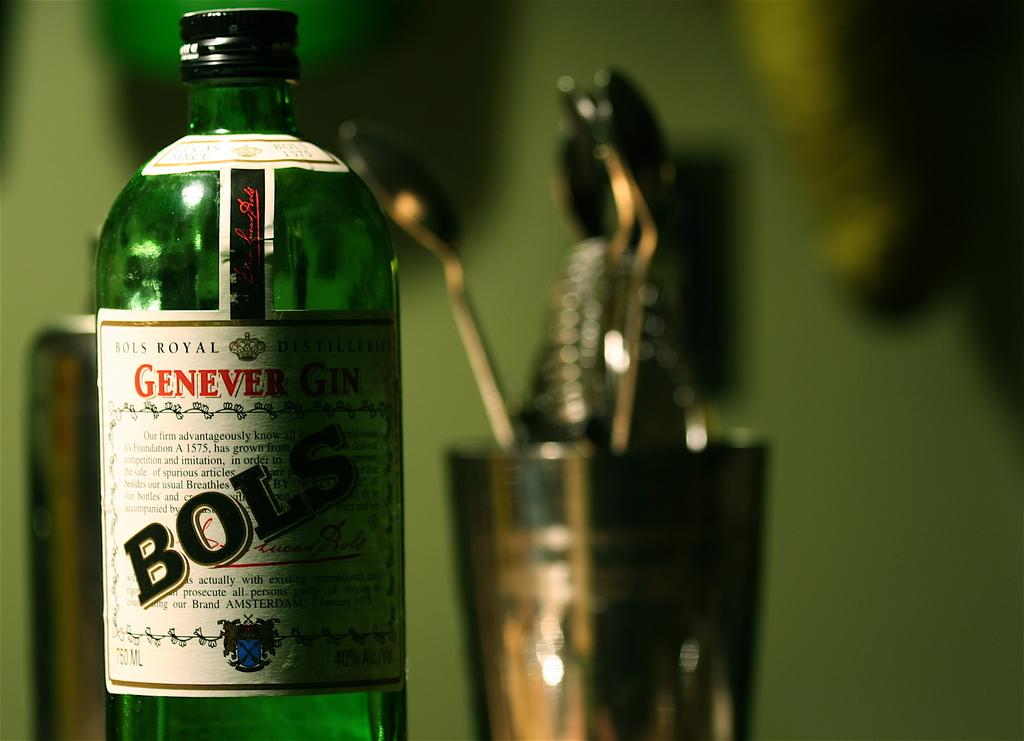What is the main object in the image? There is a bottle in the image. What can be seen written on the bottle? The bottle has "BOLS" written on it. What other objects are visible in the background of the image? There is a glass and spoons in the background of the image. What type of weather can be seen in the image? There is no weather visible in the image; it is a still image of objects. 